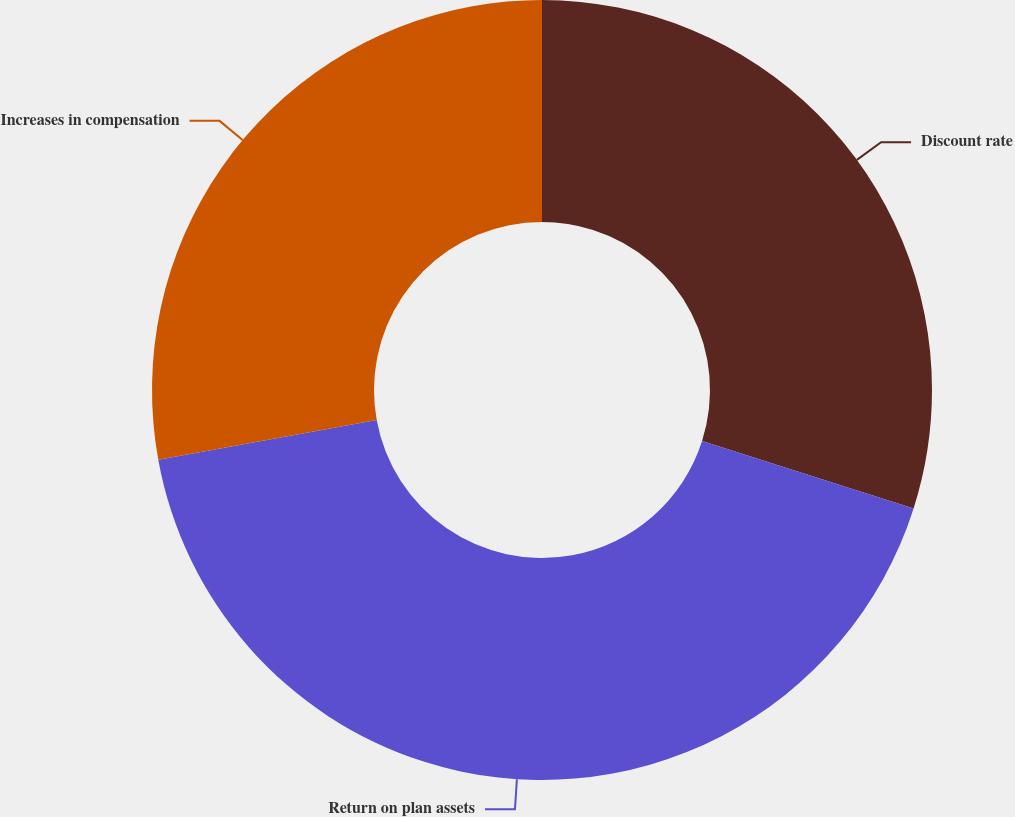Convert chart. <chart><loc_0><loc_0><loc_500><loc_500><pie_chart><fcel>Discount rate<fcel>Return on plan assets<fcel>Increases in compensation<nl><fcel>29.91%<fcel>42.23%<fcel>27.86%<nl></chart> 